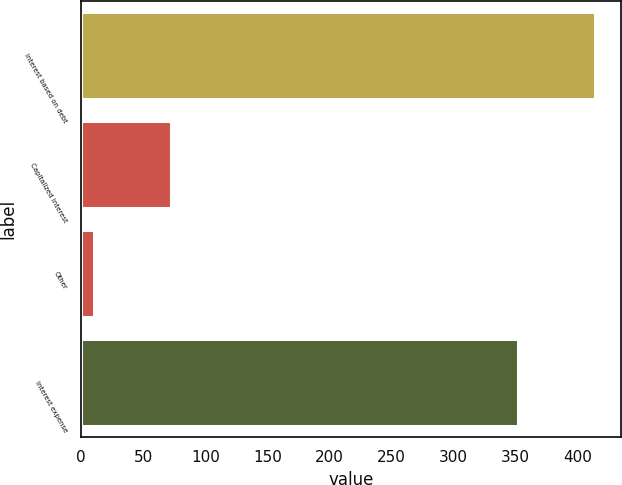Convert chart. <chart><loc_0><loc_0><loc_500><loc_500><bar_chart><fcel>Interest based on debt<fcel>Capitalized interest<fcel>Other<fcel>Interest expense<nl><fcel>414<fcel>72<fcel>10<fcel>352<nl></chart> 